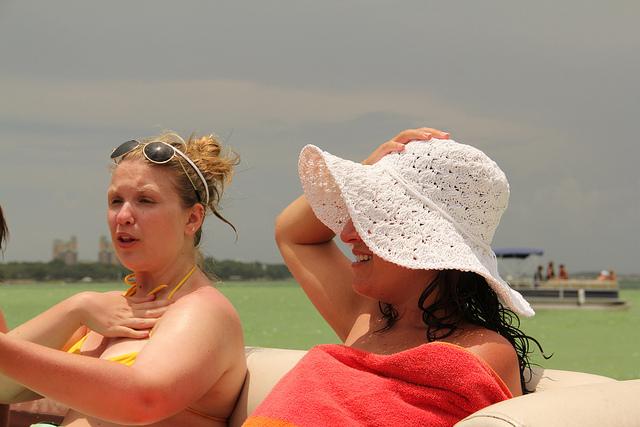What is the physique of the person in the foreground?
Keep it brief. Overweight. What are they doing?
Be succinct. Sunbathing. Which function is this?
Answer briefly. Boating. What is the lady on the right's right hand doing?
Be succinct. Holding her hat. Is this outdoors?
Short answer required. Yes. What are the girls sitting on?
Concise answer only. Couch. Is she wearing a hat?
Short answer required. Yes. Are they dressed for work?
Be succinct. No. What kind of hat is the person wearing?
Be succinct. Sun hat. Do both girls have parts in their hair?
Be succinct. No. What kind of hat is she wearing?
Short answer required. Sun hat. 